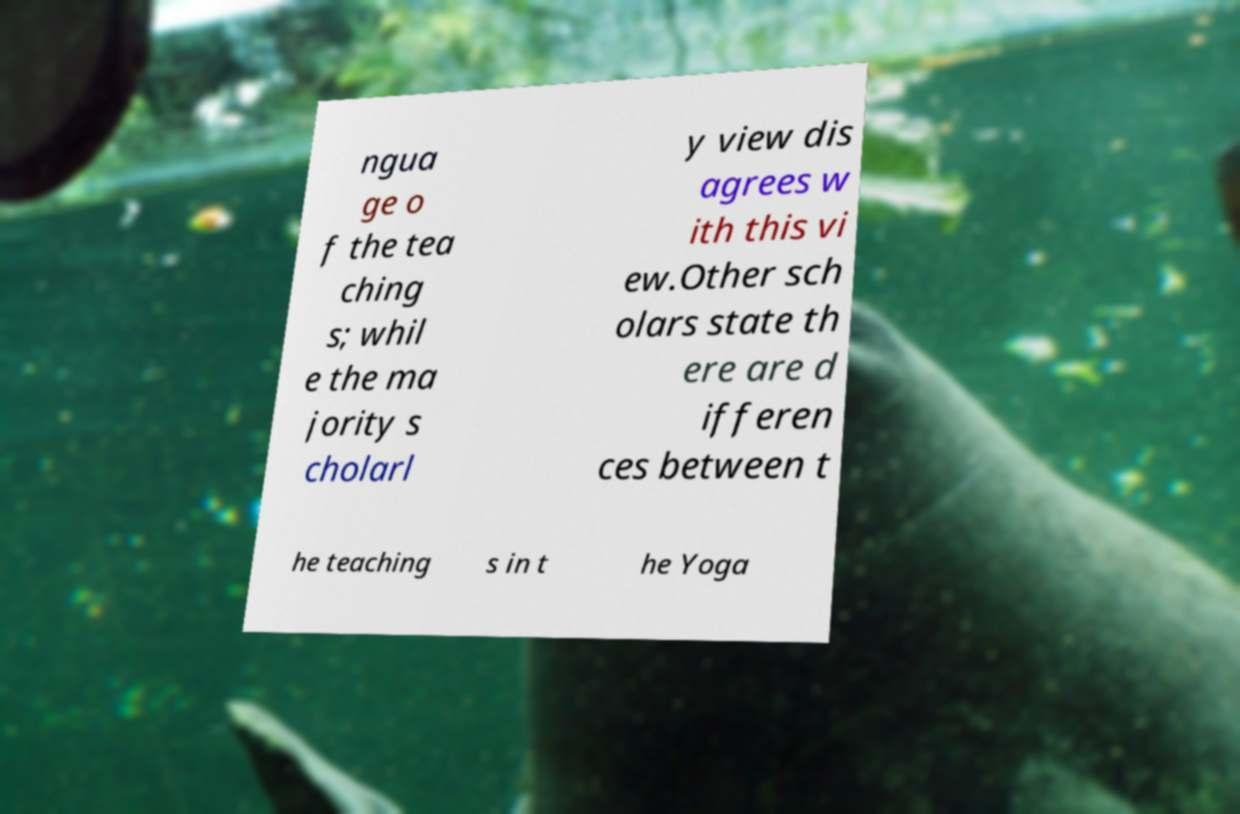There's text embedded in this image that I need extracted. Can you transcribe it verbatim? ngua ge o f the tea ching s; whil e the ma jority s cholarl y view dis agrees w ith this vi ew.Other sch olars state th ere are d ifferen ces between t he teaching s in t he Yoga 